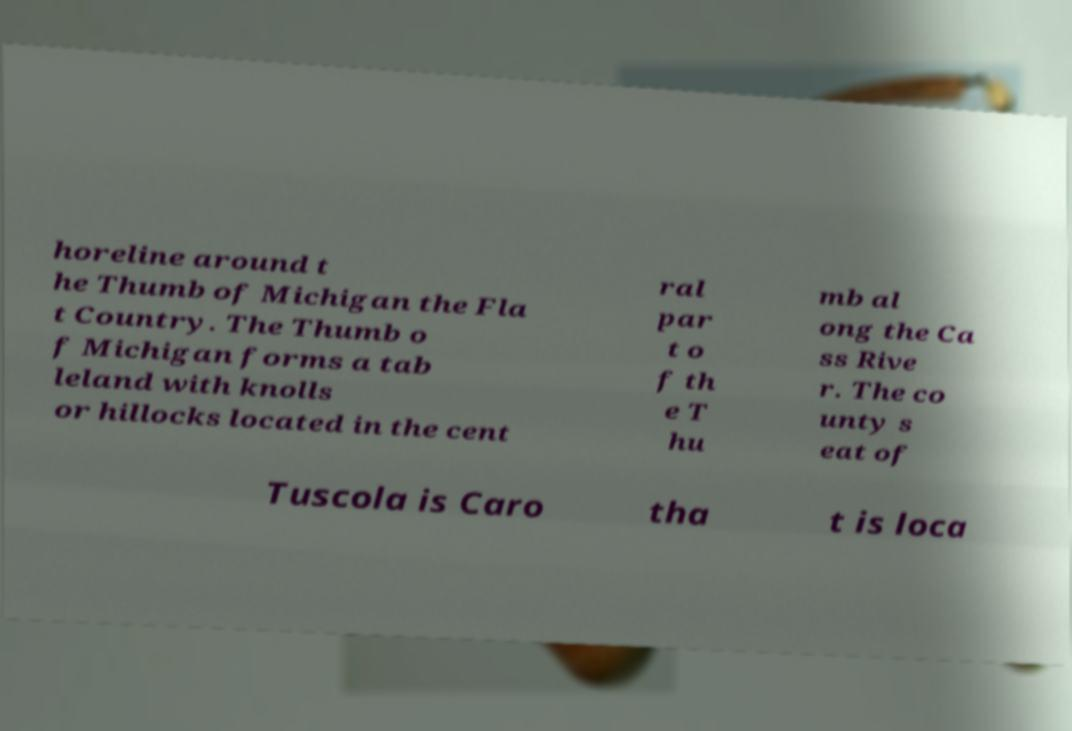Could you assist in decoding the text presented in this image and type it out clearly? horeline around t he Thumb of Michigan the Fla t Country. The Thumb o f Michigan forms a tab leland with knolls or hillocks located in the cent ral par t o f th e T hu mb al ong the Ca ss Rive r. The co unty s eat of Tuscola is Caro tha t is loca 